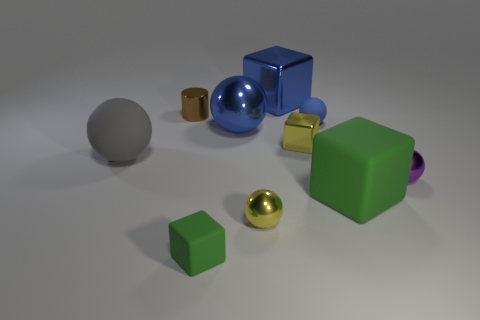There is a object left of the brown thing; what material is it?
Offer a terse response. Rubber. What size is the yellow metal thing that is the same shape as the big gray rubber object?
Provide a short and direct response. Small. How many small brown objects are made of the same material as the tiny yellow block?
Make the answer very short. 1. What number of balls have the same color as the large metallic cube?
Offer a terse response. 2. How many objects are cubes behind the blue matte sphere or things that are in front of the purple ball?
Give a very brief answer. 4. Is the number of gray matte balls that are in front of the yellow metallic sphere less than the number of tiny metallic spheres?
Provide a succinct answer. Yes. Are there any spheres of the same size as the purple object?
Ensure brevity in your answer.  Yes. The large rubber ball is what color?
Your answer should be very brief. Gray. Is the size of the purple shiny thing the same as the blue matte thing?
Your response must be concise. Yes. What number of objects are large metal blocks or shiny objects?
Keep it short and to the point. 6. 